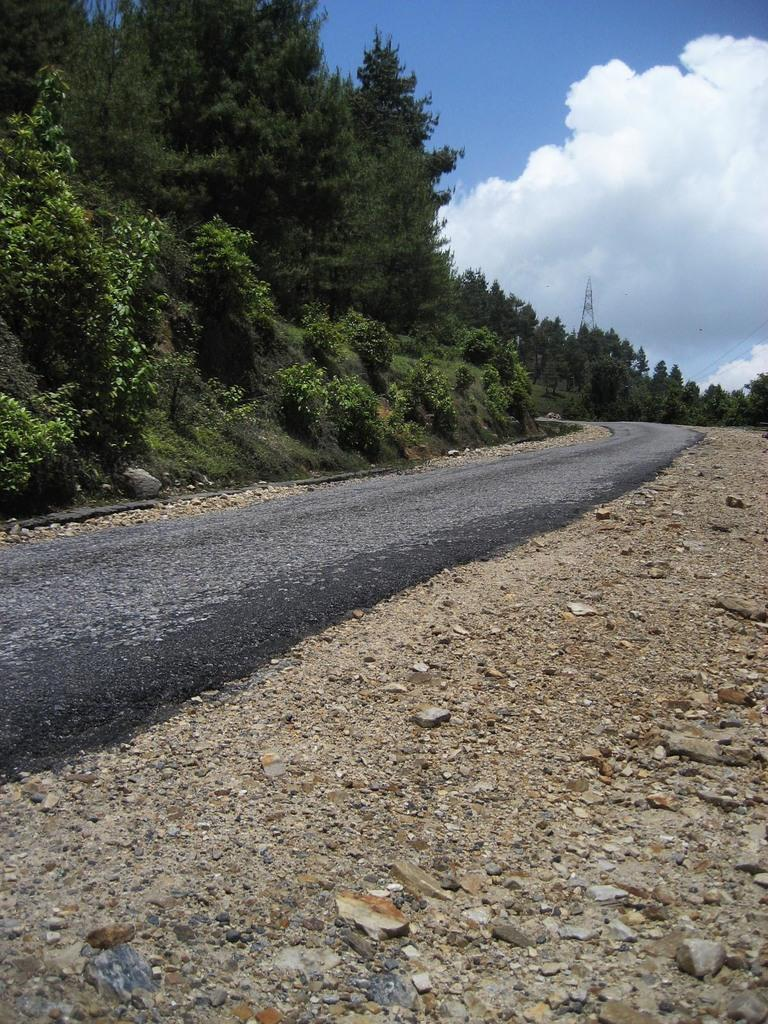What type of natural elements can be seen at the bottom of the image? There are stones in the image. What man-made structure is present at the bottom of the image? There is a road in the image. Where are the stones and road located in relation to the rest of the image? The stones and road are at the bottom of the image. What can be seen in the background of the image? There are trees in the background of the image. What is visible in the sky in the image? The sky is visible in the image, and clouds are present. Can you tell me how many goldfish are swimming in the river in the image? There is no river or goldfish present in the image. What type of rhythm can be heard coming from the trees in the background? There is no sound or rhythm associated with the trees in the image. 